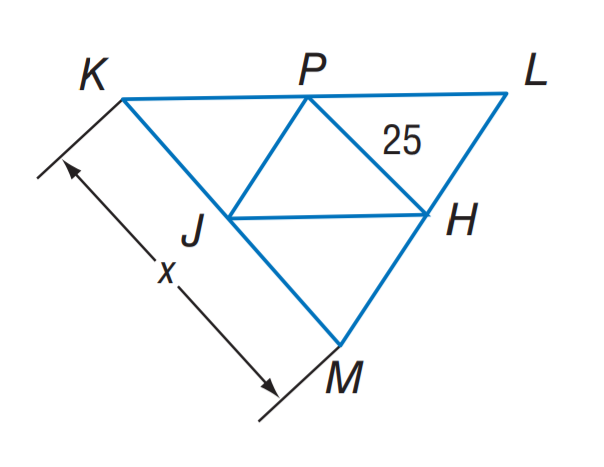Answer the mathemtical geometry problem and directly provide the correct option letter.
Question: J H, J P, and P H are midsegments of \triangle K L M. Find x.
Choices: A: 12.5 B: 20 C: 25 D: 50 D 